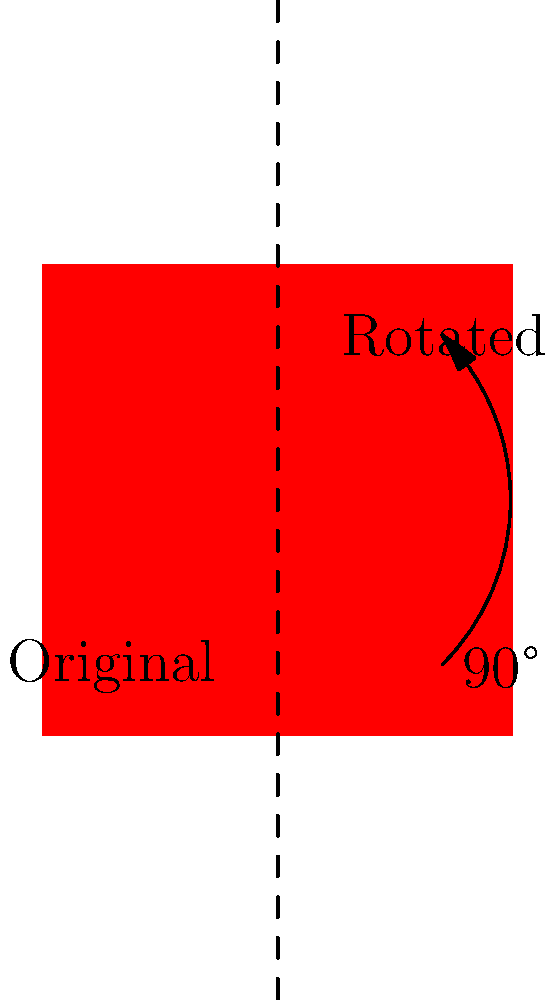For a community event banner, you need to create a symmetrical design using the school logo. The original logo is shown in blue, and you want to rotate it to create a mirror image on the other side of the banner. What angle of rotation should be applied to the original logo to achieve the desired symmetrical design as shown in the red logo? To solve this problem, let's follow these steps:

1. Observe the original logo (blue) and the desired position (red) in the diagram.

2. Notice that the logos are symmetric about the vertical dashed line, which acts as the axis of symmetry for the banner design.

3. To create a mirror image, we need to rotate the original logo so that it appears on the opposite side of the axis of symmetry.

4. In geometry, a 90° rotation clockwise (or counterclockwise) followed by a reflection across the y-axis produces the same result as a 180° rotation about the origin.

5. Since we want the logo to be symmetrical across the vertical axis, we can achieve this by rotating the original logo by 180°.

6. However, in this case, the diagram shows that the desired position (red logo) can be achieved by a single 90° rotation clockwise.

7. This 90° rotation creates the mirror image effect when combined with the original logo, resulting in the symmetrical design needed for the banner.

Therefore, the angle of rotation that should be applied to the original logo to achieve the desired symmetrical design is 90° clockwise.
Answer: 90° clockwise 